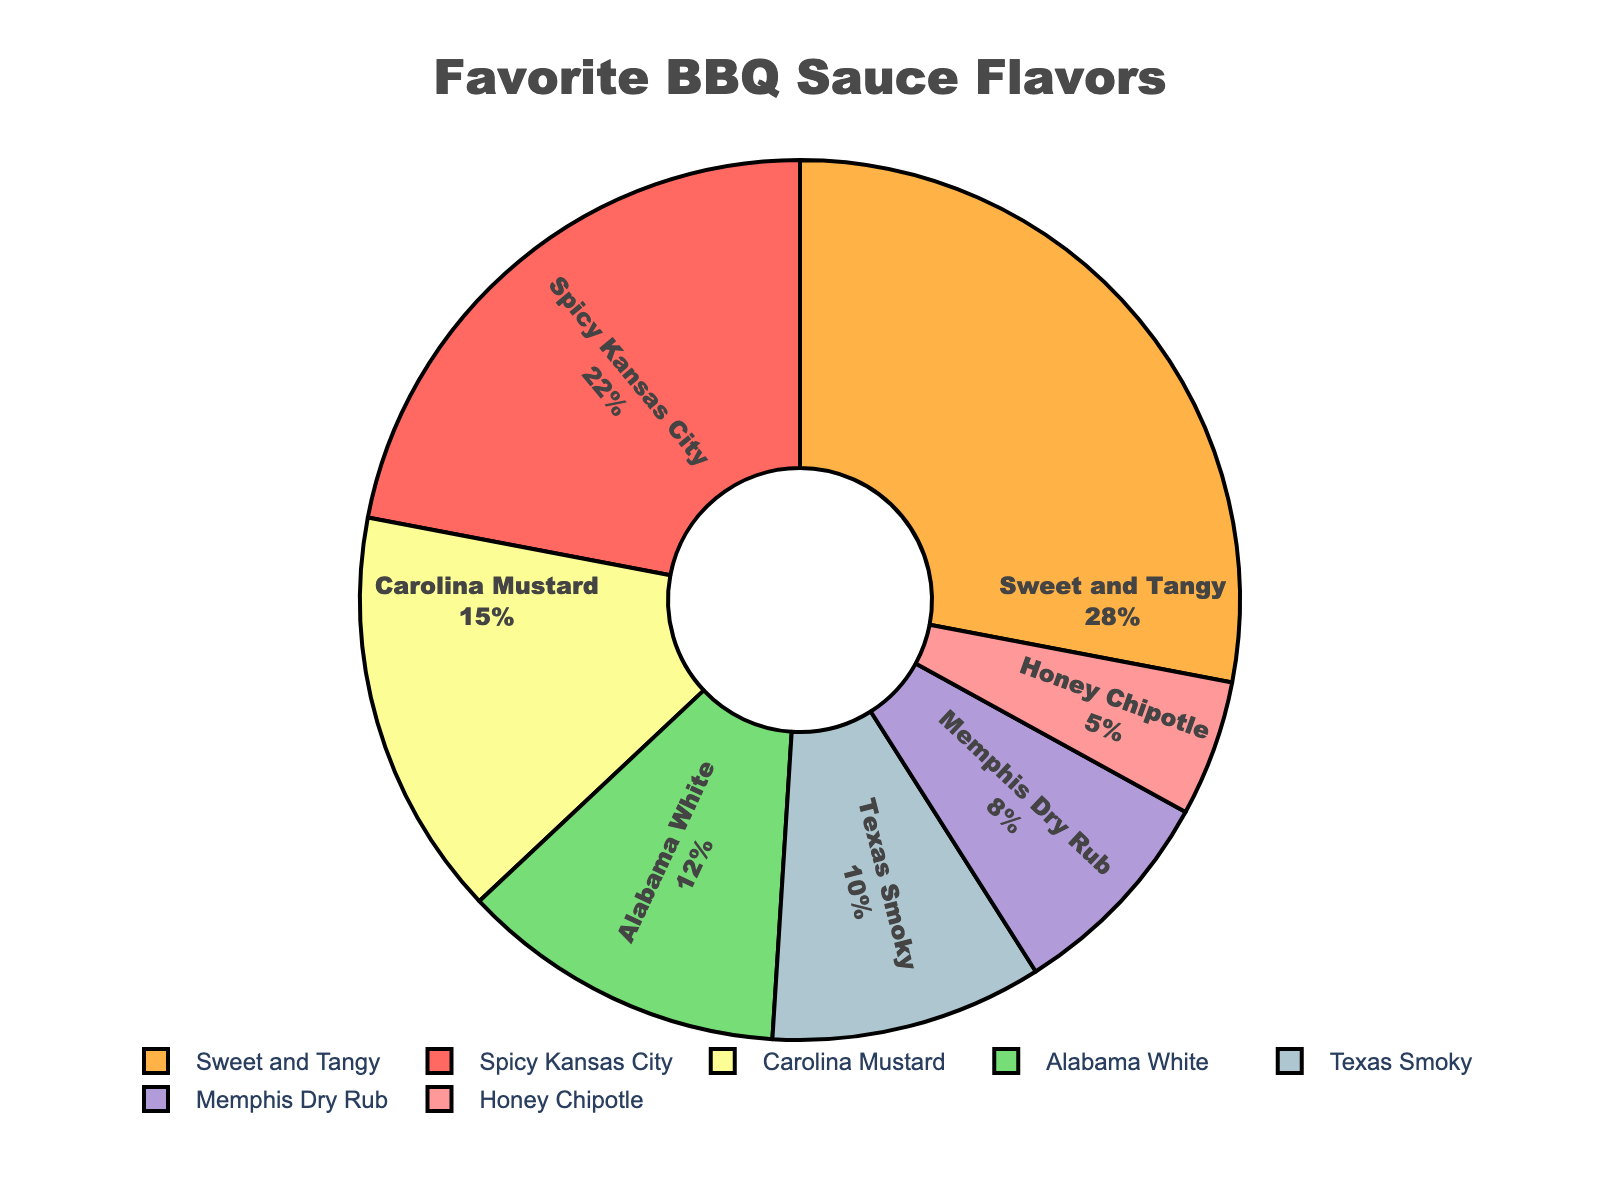Which BBQ sauce flavor is the most popular? The pie chart shows the distribution of favorite BBQ sauce flavors among customers. "Sweet and Tangy" has the largest percentage with 28%.
Answer: Sweet and Tangy What is the combined percentage of "Spicy Kansas City" and "Texas Smoky"? According to the chart, "Spicy Kansas City" has a percentage of 22% and "Texas Smoky" has 10%. Adding these together gives 22% + 10% = 32%.
Answer: 32% How much more popular is "Sweet and Tangy" compared to "Honey Chipotle"? "Sweet and Tangy" has 28% while "Honey Chipotle" has 5%. The difference is 28% - 5% = 23%.
Answer: 23% Which flavor represents the smallest segment in the pie chart? By looking at the chart, "Honey Chipotle" has the smallest segment with 5%.
Answer: Honey Chipotle What is the total percentage for "Carolina Mustard" and "Alabama White"? The chart shows "Carolina Mustard" with 15% and "Alabama White" with 12%. Adding these together results in 15% + 12% = 27%.
Answer: 27% Which flavor is more popular, "Texas Smoky" or "Memphis Dry Rub"? "Texas Smoky" has a percentage of 10% while "Memphis Dry Rub" has 8%. Therefore, "Texas Smoky" is more popular.
Answer: Texas Smoky What is the difference in popularity between "Carolina Mustard" and "Sweet and Tangy"? "Sweet and Tangy" is at 28% and "Carolina Mustard" is at 15%. The difference is 28% - 15% = 13%.
Answer: 13% If "Honey Chipotle" increased by 5%, how would its new percentage compare to "Memphis Dry Rub"? "Honey Chipotle" currently has 5%. If it increased by 5%, it would be 5% + 5% = 10%. This is equal to the current percentage of "Memphis Dry Rub" which is also 10%.
Answer: Equal Which flavor's segment color is represented by green in the pie chart? Reviewing the visual attributes of the chart, "Texas Smoky" is assigned a green color.
Answer: Texas Smoky 